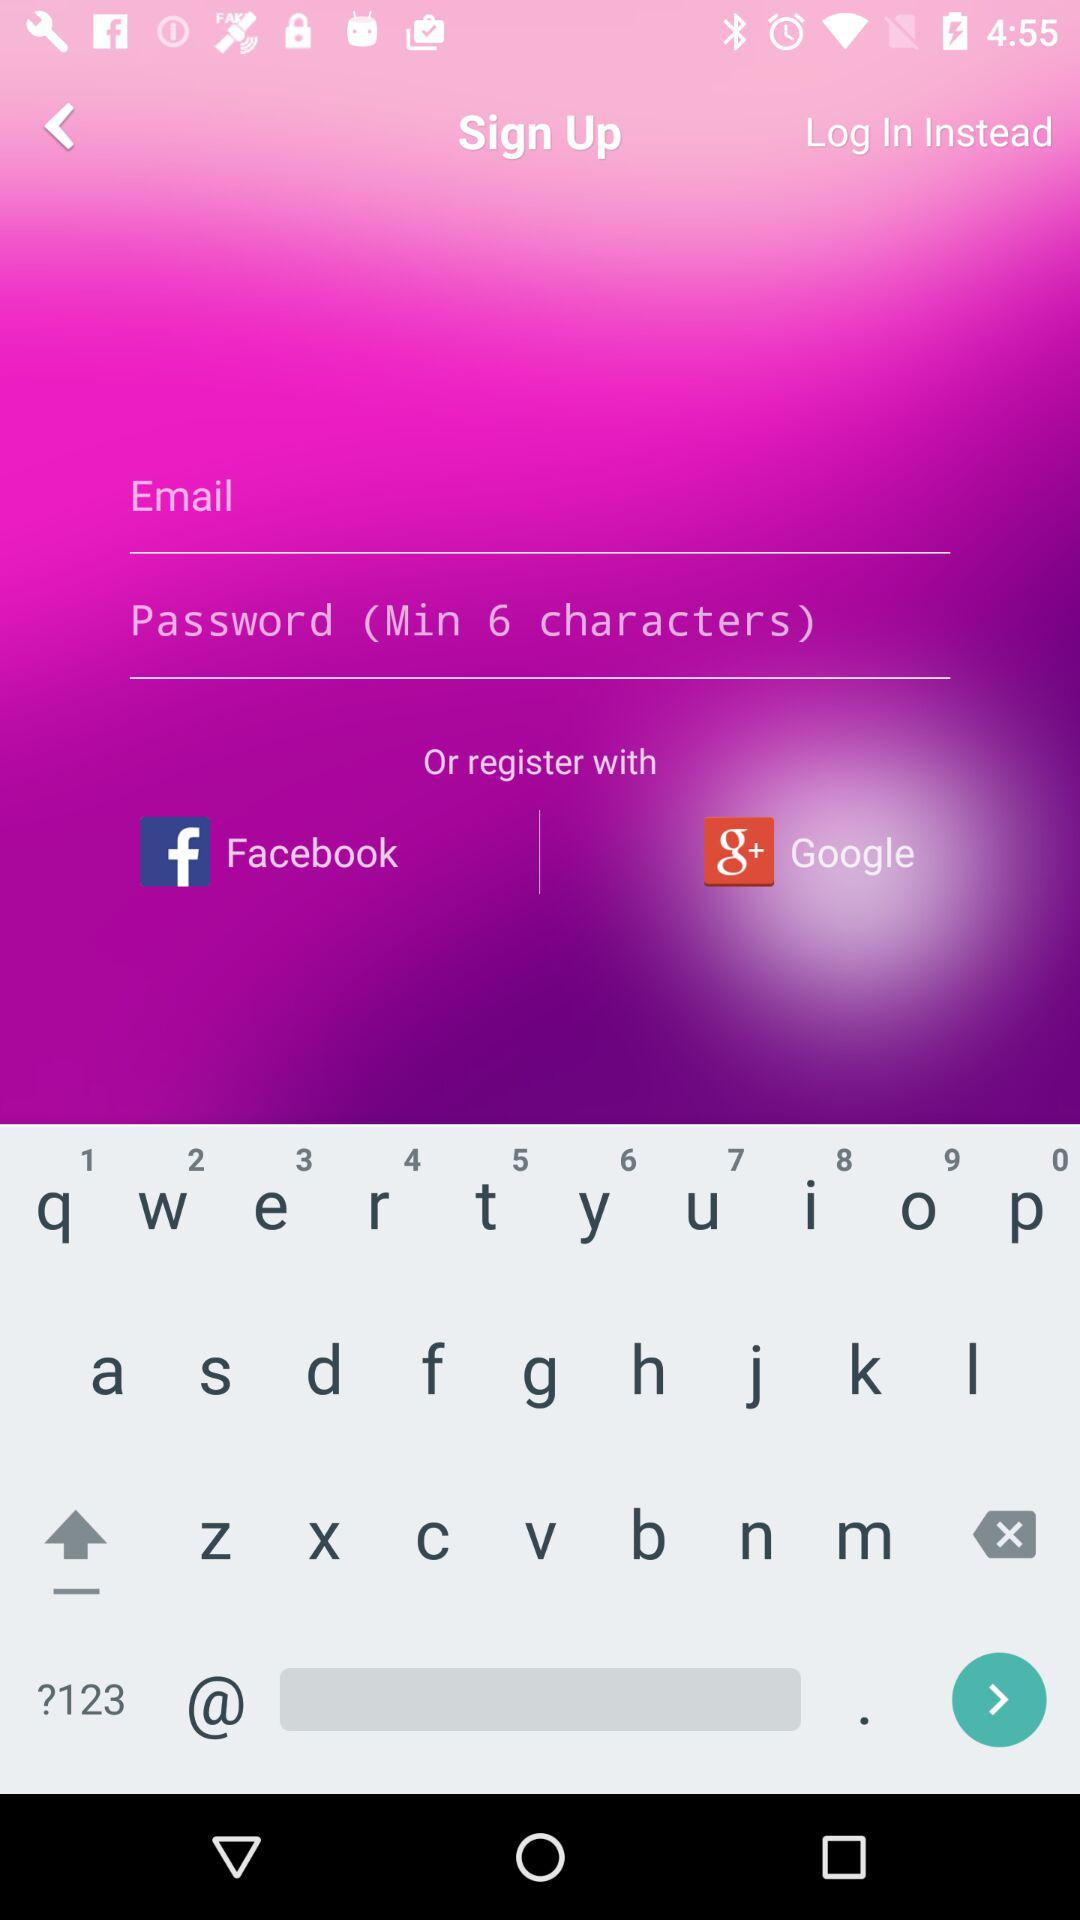How many social media login options are available?
Answer the question using a single word or phrase. 2 